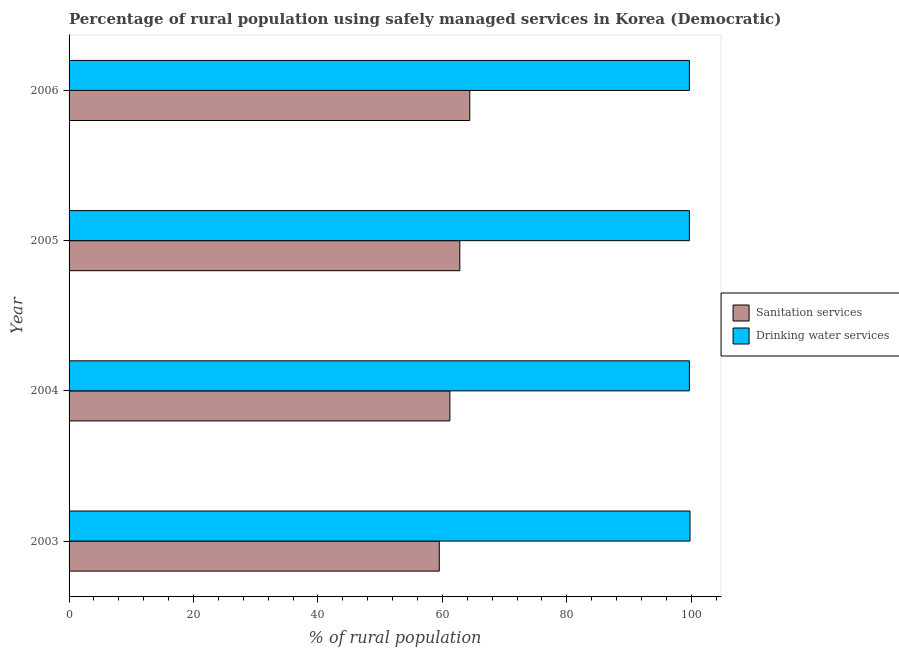How many different coloured bars are there?
Provide a short and direct response. 2. How many groups of bars are there?
Make the answer very short. 4. Are the number of bars on each tick of the Y-axis equal?
Ensure brevity in your answer.  Yes. How many bars are there on the 1st tick from the top?
Give a very brief answer. 2. How many bars are there on the 3rd tick from the bottom?
Your response must be concise. 2. What is the percentage of rural population who used drinking water services in 2006?
Keep it short and to the point. 99.7. Across all years, what is the maximum percentage of rural population who used sanitation services?
Your answer should be compact. 64.4. Across all years, what is the minimum percentage of rural population who used drinking water services?
Offer a terse response. 99.7. In which year was the percentage of rural population who used sanitation services minimum?
Your answer should be compact. 2003. What is the total percentage of rural population who used sanitation services in the graph?
Provide a succinct answer. 247.9. What is the difference between the percentage of rural population who used sanitation services in 2005 and the percentage of rural population who used drinking water services in 2006?
Provide a succinct answer. -36.9. What is the average percentage of rural population who used drinking water services per year?
Offer a very short reply. 99.72. In the year 2006, what is the difference between the percentage of rural population who used drinking water services and percentage of rural population who used sanitation services?
Offer a terse response. 35.3. What is the ratio of the percentage of rural population who used sanitation services in 2003 to that in 2004?
Your answer should be very brief. 0.97. Is the percentage of rural population who used drinking water services in 2004 less than that in 2005?
Keep it short and to the point. No. What is the difference between the highest and the second highest percentage of rural population who used drinking water services?
Make the answer very short. 0.1. In how many years, is the percentage of rural population who used sanitation services greater than the average percentage of rural population who used sanitation services taken over all years?
Ensure brevity in your answer.  2. What does the 1st bar from the top in 2003 represents?
Your response must be concise. Drinking water services. What does the 2nd bar from the bottom in 2005 represents?
Make the answer very short. Drinking water services. How many bars are there?
Give a very brief answer. 8. How many years are there in the graph?
Ensure brevity in your answer.  4. What is the difference between two consecutive major ticks on the X-axis?
Offer a very short reply. 20. Are the values on the major ticks of X-axis written in scientific E-notation?
Give a very brief answer. No. How are the legend labels stacked?
Make the answer very short. Vertical. What is the title of the graph?
Your response must be concise. Percentage of rural population using safely managed services in Korea (Democratic). Does "Urban" appear as one of the legend labels in the graph?
Ensure brevity in your answer.  No. What is the label or title of the X-axis?
Your response must be concise. % of rural population. What is the % of rural population in Sanitation services in 2003?
Keep it short and to the point. 59.5. What is the % of rural population of Drinking water services in 2003?
Provide a succinct answer. 99.8. What is the % of rural population of Sanitation services in 2004?
Your answer should be compact. 61.2. What is the % of rural population of Drinking water services in 2004?
Provide a succinct answer. 99.7. What is the % of rural population in Sanitation services in 2005?
Make the answer very short. 62.8. What is the % of rural population in Drinking water services in 2005?
Provide a short and direct response. 99.7. What is the % of rural population in Sanitation services in 2006?
Give a very brief answer. 64.4. What is the % of rural population in Drinking water services in 2006?
Provide a succinct answer. 99.7. Across all years, what is the maximum % of rural population in Sanitation services?
Your answer should be very brief. 64.4. Across all years, what is the maximum % of rural population in Drinking water services?
Your response must be concise. 99.8. Across all years, what is the minimum % of rural population in Sanitation services?
Provide a succinct answer. 59.5. Across all years, what is the minimum % of rural population of Drinking water services?
Ensure brevity in your answer.  99.7. What is the total % of rural population in Sanitation services in the graph?
Keep it short and to the point. 247.9. What is the total % of rural population of Drinking water services in the graph?
Your answer should be compact. 398.9. What is the difference between the % of rural population in Sanitation services in 2003 and that in 2004?
Your answer should be compact. -1.7. What is the difference between the % of rural population in Drinking water services in 2003 and that in 2004?
Give a very brief answer. 0.1. What is the difference between the % of rural population of Sanitation services in 2003 and that in 2006?
Offer a terse response. -4.9. What is the difference between the % of rural population of Sanitation services in 2004 and that in 2006?
Your answer should be compact. -3.2. What is the difference between the % of rural population in Drinking water services in 2004 and that in 2006?
Keep it short and to the point. 0. What is the difference between the % of rural population in Sanitation services in 2005 and that in 2006?
Offer a terse response. -1.6. What is the difference between the % of rural population in Drinking water services in 2005 and that in 2006?
Your response must be concise. 0. What is the difference between the % of rural population in Sanitation services in 2003 and the % of rural population in Drinking water services in 2004?
Your response must be concise. -40.2. What is the difference between the % of rural population in Sanitation services in 2003 and the % of rural population in Drinking water services in 2005?
Keep it short and to the point. -40.2. What is the difference between the % of rural population of Sanitation services in 2003 and the % of rural population of Drinking water services in 2006?
Offer a terse response. -40.2. What is the difference between the % of rural population of Sanitation services in 2004 and the % of rural population of Drinking water services in 2005?
Offer a very short reply. -38.5. What is the difference between the % of rural population of Sanitation services in 2004 and the % of rural population of Drinking water services in 2006?
Make the answer very short. -38.5. What is the difference between the % of rural population in Sanitation services in 2005 and the % of rural population in Drinking water services in 2006?
Your response must be concise. -36.9. What is the average % of rural population in Sanitation services per year?
Your response must be concise. 61.98. What is the average % of rural population in Drinking water services per year?
Your answer should be very brief. 99.72. In the year 2003, what is the difference between the % of rural population in Sanitation services and % of rural population in Drinking water services?
Provide a succinct answer. -40.3. In the year 2004, what is the difference between the % of rural population in Sanitation services and % of rural population in Drinking water services?
Provide a short and direct response. -38.5. In the year 2005, what is the difference between the % of rural population in Sanitation services and % of rural population in Drinking water services?
Offer a terse response. -36.9. In the year 2006, what is the difference between the % of rural population in Sanitation services and % of rural population in Drinking water services?
Offer a terse response. -35.3. What is the ratio of the % of rural population in Sanitation services in 2003 to that in 2004?
Keep it short and to the point. 0.97. What is the ratio of the % of rural population in Drinking water services in 2003 to that in 2004?
Offer a very short reply. 1. What is the ratio of the % of rural population in Sanitation services in 2003 to that in 2005?
Your answer should be compact. 0.95. What is the ratio of the % of rural population of Drinking water services in 2003 to that in 2005?
Your response must be concise. 1. What is the ratio of the % of rural population in Sanitation services in 2003 to that in 2006?
Provide a short and direct response. 0.92. What is the ratio of the % of rural population in Sanitation services in 2004 to that in 2005?
Keep it short and to the point. 0.97. What is the ratio of the % of rural population in Drinking water services in 2004 to that in 2005?
Your answer should be compact. 1. What is the ratio of the % of rural population of Sanitation services in 2004 to that in 2006?
Give a very brief answer. 0.95. What is the ratio of the % of rural population of Drinking water services in 2004 to that in 2006?
Offer a very short reply. 1. What is the ratio of the % of rural population of Sanitation services in 2005 to that in 2006?
Make the answer very short. 0.98. What is the difference between the highest and the second highest % of rural population of Drinking water services?
Make the answer very short. 0.1. What is the difference between the highest and the lowest % of rural population in Sanitation services?
Offer a terse response. 4.9. What is the difference between the highest and the lowest % of rural population in Drinking water services?
Make the answer very short. 0.1. 